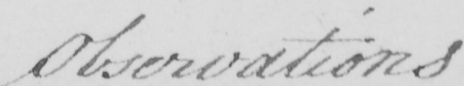Please provide the text content of this handwritten line. Observations 